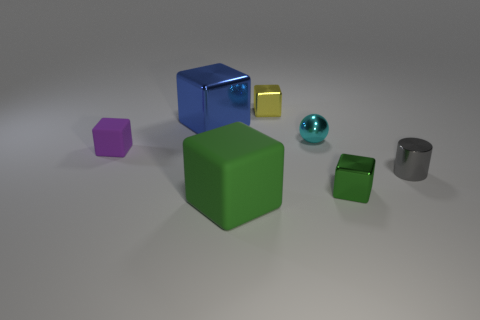Subtract all large green blocks. How many blocks are left? 4 Subtract all blue blocks. How many blocks are left? 4 Subtract all brown cubes. Subtract all gray cylinders. How many cubes are left? 5 Add 1 tiny green rubber cubes. How many objects exist? 8 Subtract all cylinders. How many objects are left? 6 Add 3 tiny brown metallic blocks. How many tiny brown metallic blocks exist? 3 Subtract 2 green blocks. How many objects are left? 5 Subtract all tiny yellow metal things. Subtract all big metal cubes. How many objects are left? 5 Add 7 small cyan spheres. How many small cyan spheres are left? 8 